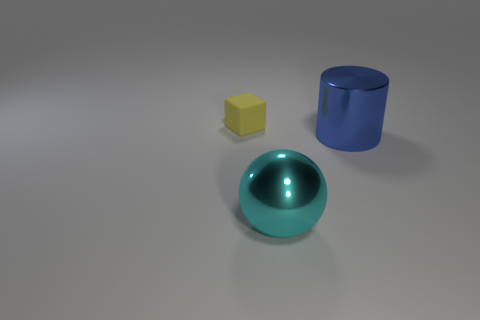What type of books might the person who uses this reading nook prefer, based on the setting and ambiance of the nook? The image provided does not display a reading nook but rather shows simple geometric shapes (a yellow cube, a blue cylinder, and a green sphere) on a plain surface, which seems to be more of a basic 3D modeling scene. Therefore, it's not possible to determine any preferences about books from this image. 